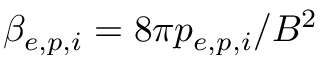Convert formula to latex. <formula><loc_0><loc_0><loc_500><loc_500>\beta _ { e , p , i } = 8 \pi p _ { e , p , i } / B ^ { 2 }</formula> 